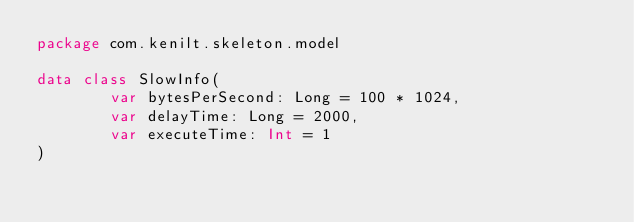Convert code to text. <code><loc_0><loc_0><loc_500><loc_500><_Kotlin_>package com.kenilt.skeleton.model

data class SlowInfo(
        var bytesPerSecond: Long = 100 * 1024,
        var delayTime: Long = 2000,
        var executeTime: Int = 1
)
</code> 